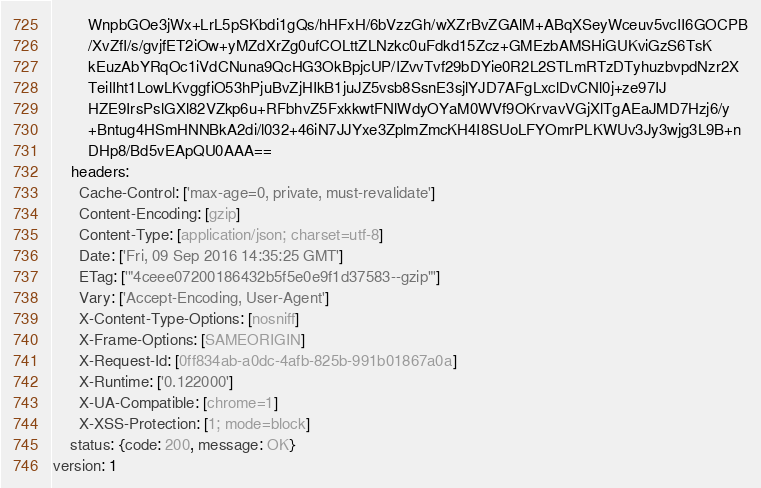Convert code to text. <code><loc_0><loc_0><loc_500><loc_500><_YAML_>        WnpbGOe3jWx+LrL5pSKbdi1gQs/hHFxH/6bVzzGh/wXZrBvZGAlM+ABqXSeyWceuv5vcII6GOCPB
        /XvZfI/s/gvjfET2iOw+yMZdXrZg0ufCOLttZLNzkc0uFdkd15Zcz+GMEzbAMSHiGUKviGzS6TsK
        kEuzAbYRqOc1iVdCNuna9QcHG3OkBpjcUP/IZvvTvf29bDYie0R2L2STLmRTzDTyhuzbvpdNzr2X
        TeilIht1LowLKvggfiO53hPjuBvZjHIkB1juJZ5vsb8SsnE3sjlYJD7AFgLxclDvCNl0j+ze97IJ
        HZE9IrsPslGXl82VZkp6u+RFbhvZ5FxkkwtFNlWdyOYaM0WVf9OKrvavVGjXlTgAEaJMD7Hzj6/y
        +Bntug4HSmHNNBkA2di/l032+46iN7JJYxe3ZplmZmcKH4I8SUoLFYOmrPLKWUv3Jy3wjg3L9B+n
        DHp8/Bd5vEApQU0AAA==
    headers:
      Cache-Control: ['max-age=0, private, must-revalidate']
      Content-Encoding: [gzip]
      Content-Type: [application/json; charset=utf-8]
      Date: ['Fri, 09 Sep 2016 14:35:25 GMT']
      ETag: ['"4ceee07200186432b5f5e0e9f1d37583--gzip"']
      Vary: ['Accept-Encoding, User-Agent']
      X-Content-Type-Options: [nosniff]
      X-Frame-Options: [SAMEORIGIN]
      X-Request-Id: [0ff834ab-a0dc-4afb-825b-991b01867a0a]
      X-Runtime: ['0.122000']
      X-UA-Compatible: [chrome=1]
      X-XSS-Protection: [1; mode=block]
    status: {code: 200, message: OK}
version: 1
</code> 